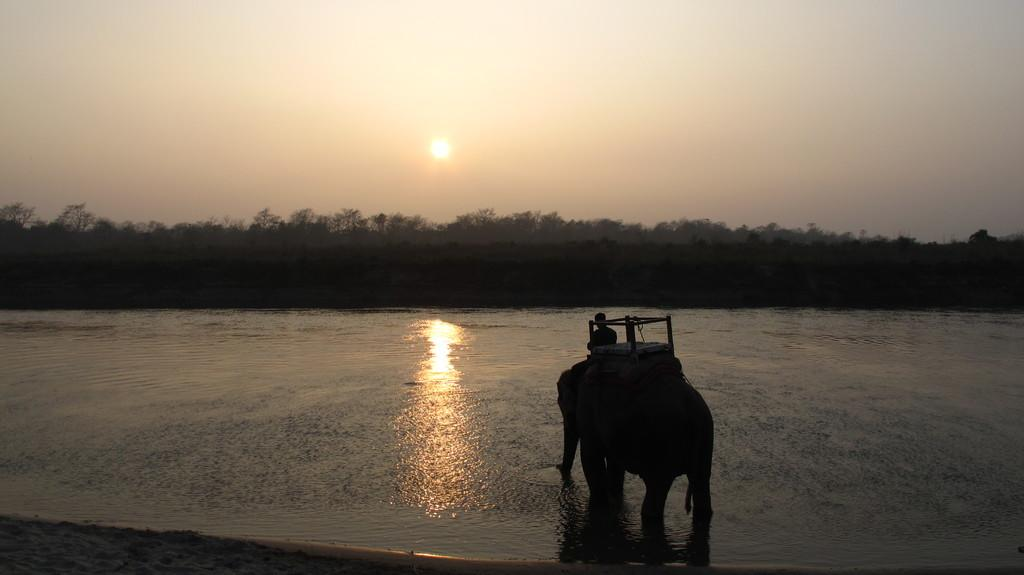What animal is the main subject of the picture? There is an elephant in the picture. What is on top of the elephant? The elephant has a howdah. Who is riding the elephant? A person is sitting on the elephant. What can be seen in front of the elephant? There are trees and water visible in front of the elephant. What is visible in the background of the image? The sky is visible in the image. How many veins can be seen on the elephant's trunk in the image? There are no veins visible on the elephant's trunk in the image. What is the chance of seeing a flock of birds in the image? There are no birds visible in the image. 